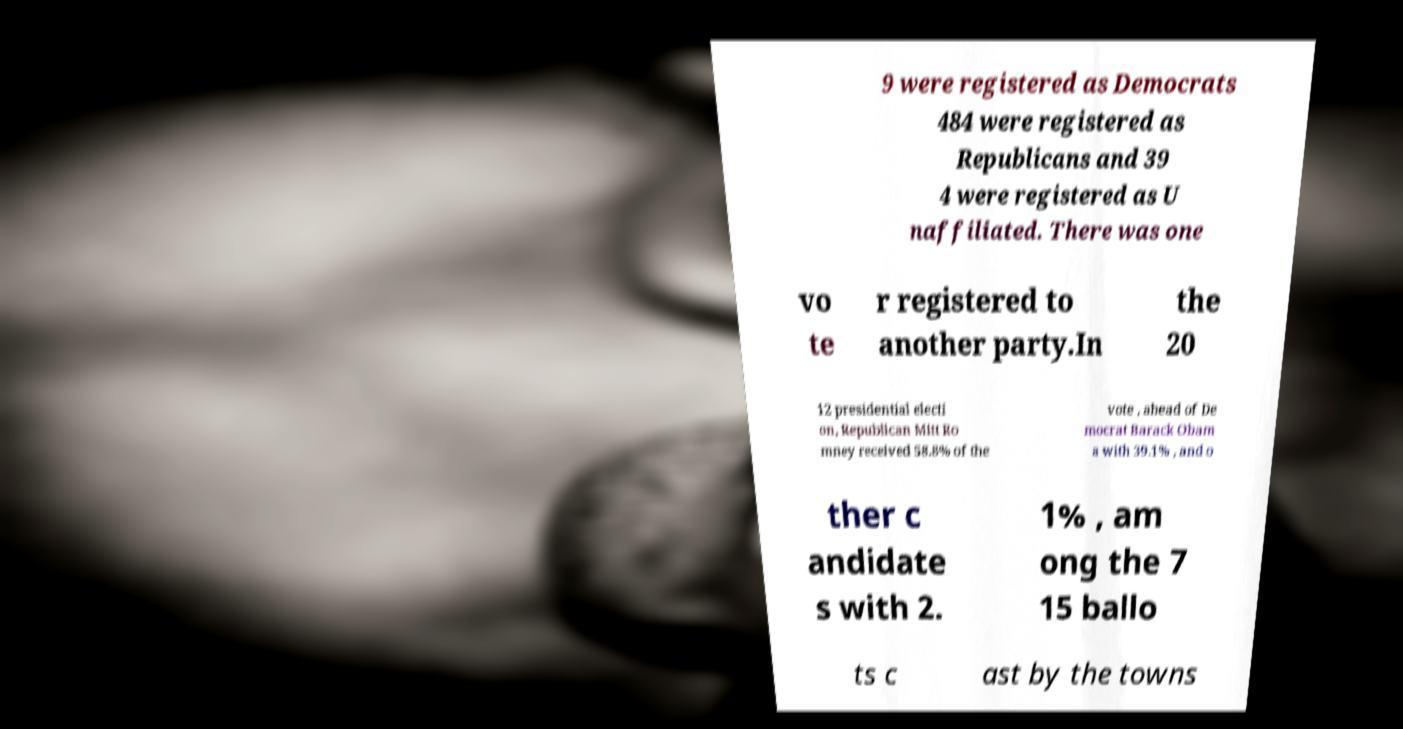There's text embedded in this image that I need extracted. Can you transcribe it verbatim? 9 were registered as Democrats 484 were registered as Republicans and 39 4 were registered as U naffiliated. There was one vo te r registered to another party.In the 20 12 presidential electi on, Republican Mitt Ro mney received 58.8% of the vote , ahead of De mocrat Barack Obam a with 39.1% , and o ther c andidate s with 2. 1% , am ong the 7 15 ballo ts c ast by the towns 